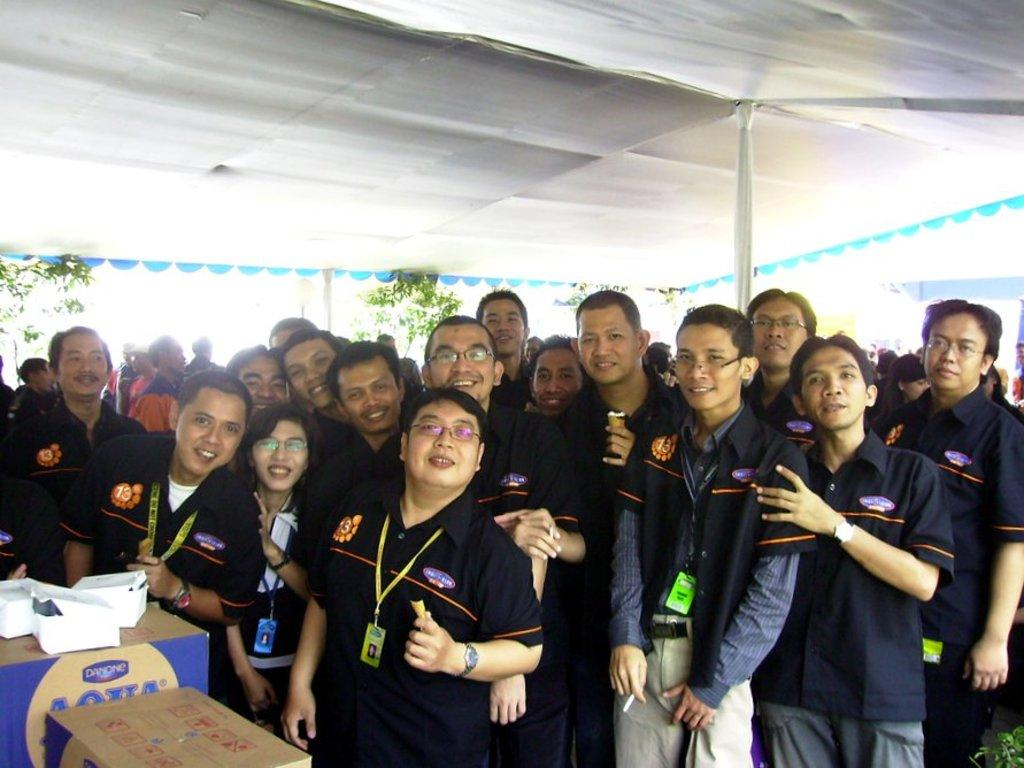How many people are in the image? There is a group of people in the image. What are the people doing in the image? The people are standing and smiling. What can be seen in the background of the image? There are plants in the background of the image. What is located on the left side of the image? There are cartons on the left side of the image. What structure is present in the image? There is a tent in the image. What type of oranges are being used as decorations in the image? There are no oranges present in the image; it features a group of people, plants, cartons, and a tent. Can you tell me how many achievers are visible in the image? The term "achiever" is not mentioned in the image, and there is no indication of any achievements or awards being presented. 